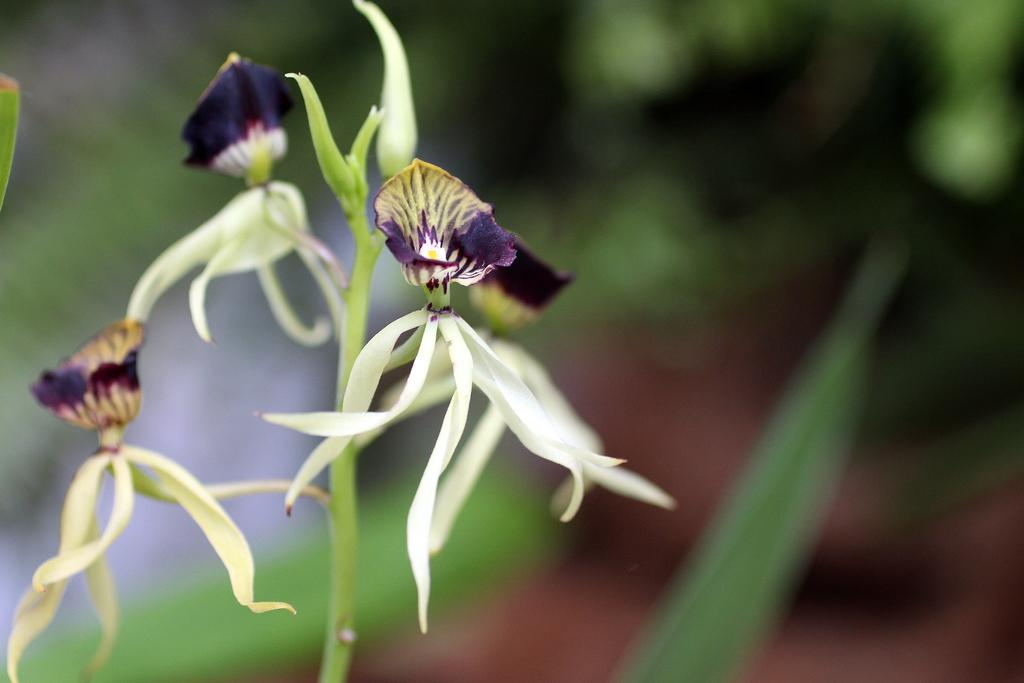What type of flora can be seen in the image? There are flowers and a plant in the image. How does the background of the image appear? The background of the image is blurred. What type of ring can be seen on the plant in the image? There is no ring present on the plant in the image. What financial interest does the plant have in the image? The plant does not have any financial interest in the image, as it is an inanimate object. 